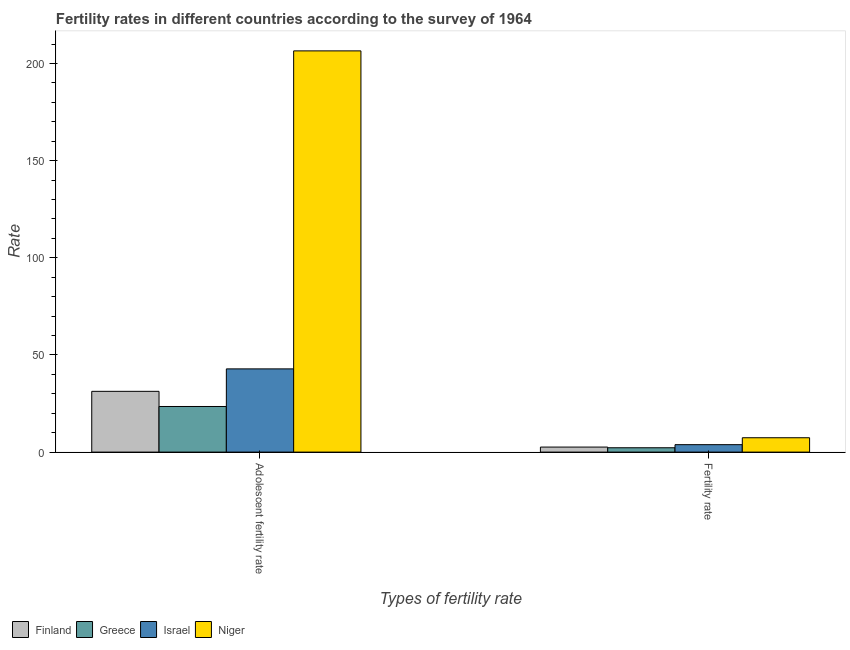How many different coloured bars are there?
Ensure brevity in your answer.  4. Are the number of bars on each tick of the X-axis equal?
Keep it short and to the point. Yes. What is the label of the 2nd group of bars from the left?
Provide a succinct answer. Fertility rate. What is the fertility rate in Israel?
Offer a very short reply. 3.83. Across all countries, what is the maximum fertility rate?
Your response must be concise. 7.39. Across all countries, what is the minimum adolescent fertility rate?
Give a very brief answer. 23.47. In which country was the fertility rate maximum?
Ensure brevity in your answer.  Niger. What is the total adolescent fertility rate in the graph?
Offer a very short reply. 304.1. What is the difference between the fertility rate in Niger and that in Israel?
Keep it short and to the point. 3.56. What is the difference between the adolescent fertility rate in Niger and the fertility rate in Israel?
Your response must be concise. 202.69. What is the average fertility rate per country?
Make the answer very short. 4.01. What is the difference between the fertility rate and adolescent fertility rate in Israel?
Ensure brevity in your answer.  -39.01. In how many countries, is the adolescent fertility rate greater than 170 ?
Provide a short and direct response. 1. What is the ratio of the fertility rate in Finland to that in Niger?
Your answer should be compact. 0.35. Is the fertility rate in Niger less than that in Israel?
Offer a very short reply. No. What does the 1st bar from the left in Adolescent fertility rate represents?
Provide a succinct answer. Finland. How many bars are there?
Ensure brevity in your answer.  8. Are all the bars in the graph horizontal?
Your response must be concise. No. How many countries are there in the graph?
Provide a succinct answer. 4. What is the difference between two consecutive major ticks on the Y-axis?
Offer a terse response. 50. Does the graph contain any zero values?
Keep it short and to the point. No. Where does the legend appear in the graph?
Your answer should be very brief. Bottom left. How many legend labels are there?
Your answer should be compact. 4. How are the legend labels stacked?
Provide a succinct answer. Horizontal. What is the title of the graph?
Provide a short and direct response. Fertility rates in different countries according to the survey of 1964. What is the label or title of the X-axis?
Provide a short and direct response. Types of fertility rate. What is the label or title of the Y-axis?
Ensure brevity in your answer.  Rate. What is the Rate in Finland in Adolescent fertility rate?
Give a very brief answer. 31.28. What is the Rate in Greece in Adolescent fertility rate?
Your answer should be very brief. 23.47. What is the Rate in Israel in Adolescent fertility rate?
Your answer should be compact. 42.83. What is the Rate in Niger in Adolescent fertility rate?
Give a very brief answer. 206.52. What is the Rate of Finland in Fertility rate?
Provide a short and direct response. 2.59. What is the Rate of Greece in Fertility rate?
Provide a short and direct response. 2.24. What is the Rate of Israel in Fertility rate?
Make the answer very short. 3.83. What is the Rate of Niger in Fertility rate?
Offer a terse response. 7.39. Across all Types of fertility rate, what is the maximum Rate in Finland?
Provide a succinct answer. 31.28. Across all Types of fertility rate, what is the maximum Rate of Greece?
Provide a short and direct response. 23.47. Across all Types of fertility rate, what is the maximum Rate of Israel?
Ensure brevity in your answer.  42.83. Across all Types of fertility rate, what is the maximum Rate in Niger?
Offer a terse response. 206.52. Across all Types of fertility rate, what is the minimum Rate of Finland?
Offer a terse response. 2.59. Across all Types of fertility rate, what is the minimum Rate of Greece?
Keep it short and to the point. 2.24. Across all Types of fertility rate, what is the minimum Rate in Israel?
Ensure brevity in your answer.  3.83. Across all Types of fertility rate, what is the minimum Rate in Niger?
Provide a short and direct response. 7.39. What is the total Rate in Finland in the graph?
Your answer should be compact. 33.87. What is the total Rate in Greece in the graph?
Your answer should be very brief. 25.71. What is the total Rate in Israel in the graph?
Your response must be concise. 46.66. What is the total Rate of Niger in the graph?
Provide a short and direct response. 213.91. What is the difference between the Rate of Finland in Adolescent fertility rate and that in Fertility rate?
Offer a terse response. 28.69. What is the difference between the Rate in Greece in Adolescent fertility rate and that in Fertility rate?
Provide a short and direct response. 21.23. What is the difference between the Rate of Israel in Adolescent fertility rate and that in Fertility rate?
Provide a short and direct response. 39.01. What is the difference between the Rate of Niger in Adolescent fertility rate and that in Fertility rate?
Make the answer very short. 199.13. What is the difference between the Rate in Finland in Adolescent fertility rate and the Rate in Greece in Fertility rate?
Provide a succinct answer. 29.04. What is the difference between the Rate of Finland in Adolescent fertility rate and the Rate of Israel in Fertility rate?
Ensure brevity in your answer.  27.45. What is the difference between the Rate of Finland in Adolescent fertility rate and the Rate of Niger in Fertility rate?
Offer a terse response. 23.89. What is the difference between the Rate of Greece in Adolescent fertility rate and the Rate of Israel in Fertility rate?
Give a very brief answer. 19.65. What is the difference between the Rate of Greece in Adolescent fertility rate and the Rate of Niger in Fertility rate?
Give a very brief answer. 16.08. What is the difference between the Rate in Israel in Adolescent fertility rate and the Rate in Niger in Fertility rate?
Offer a very short reply. 35.44. What is the average Rate of Finland per Types of fertility rate?
Your answer should be compact. 16.93. What is the average Rate in Greece per Types of fertility rate?
Your answer should be very brief. 12.86. What is the average Rate in Israel per Types of fertility rate?
Your answer should be very brief. 23.33. What is the average Rate in Niger per Types of fertility rate?
Your answer should be very brief. 106.95. What is the difference between the Rate in Finland and Rate in Greece in Adolescent fertility rate?
Your response must be concise. 7.8. What is the difference between the Rate in Finland and Rate in Israel in Adolescent fertility rate?
Offer a very short reply. -11.55. What is the difference between the Rate of Finland and Rate of Niger in Adolescent fertility rate?
Keep it short and to the point. -175.24. What is the difference between the Rate in Greece and Rate in Israel in Adolescent fertility rate?
Provide a succinct answer. -19.36. What is the difference between the Rate in Greece and Rate in Niger in Adolescent fertility rate?
Provide a short and direct response. -183.04. What is the difference between the Rate in Israel and Rate in Niger in Adolescent fertility rate?
Keep it short and to the point. -163.68. What is the difference between the Rate of Finland and Rate of Israel in Fertility rate?
Keep it short and to the point. -1.24. What is the difference between the Rate of Greece and Rate of Israel in Fertility rate?
Your answer should be compact. -1.59. What is the difference between the Rate in Greece and Rate in Niger in Fertility rate?
Make the answer very short. -5.15. What is the difference between the Rate in Israel and Rate in Niger in Fertility rate?
Ensure brevity in your answer.  -3.56. What is the ratio of the Rate of Finland in Adolescent fertility rate to that in Fertility rate?
Your answer should be compact. 12.08. What is the ratio of the Rate in Greece in Adolescent fertility rate to that in Fertility rate?
Ensure brevity in your answer.  10.48. What is the ratio of the Rate of Israel in Adolescent fertility rate to that in Fertility rate?
Provide a short and direct response. 11.2. What is the ratio of the Rate in Niger in Adolescent fertility rate to that in Fertility rate?
Your response must be concise. 27.95. What is the difference between the highest and the second highest Rate in Finland?
Your response must be concise. 28.69. What is the difference between the highest and the second highest Rate in Greece?
Provide a short and direct response. 21.23. What is the difference between the highest and the second highest Rate of Israel?
Give a very brief answer. 39.01. What is the difference between the highest and the second highest Rate in Niger?
Keep it short and to the point. 199.13. What is the difference between the highest and the lowest Rate of Finland?
Provide a succinct answer. 28.69. What is the difference between the highest and the lowest Rate in Greece?
Your answer should be compact. 21.23. What is the difference between the highest and the lowest Rate of Israel?
Your response must be concise. 39.01. What is the difference between the highest and the lowest Rate of Niger?
Give a very brief answer. 199.13. 